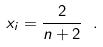<formula> <loc_0><loc_0><loc_500><loc_500>x _ { i } = \frac { 2 } { n + 2 } \ .</formula> 